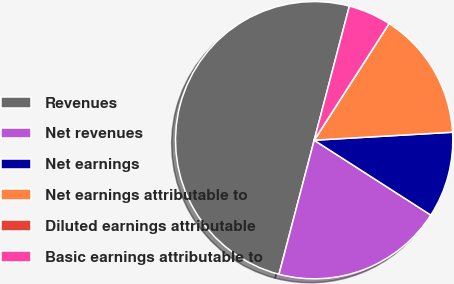<chart> <loc_0><loc_0><loc_500><loc_500><pie_chart><fcel>Revenues<fcel>Net revenues<fcel>Net earnings<fcel>Net earnings attributable to<fcel>Diluted earnings attributable<fcel>Basic earnings attributable to<nl><fcel>50.0%<fcel>20.0%<fcel>10.0%<fcel>15.0%<fcel>0.0%<fcel>5.0%<nl></chart> 